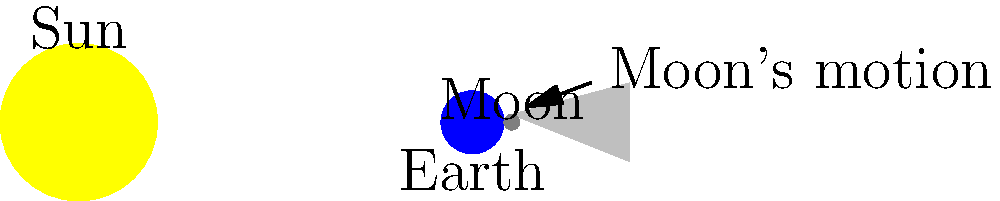In the diagram above, which represents a solar eclipse, why doesn't the contractor's shadow completely cover your view of the sun, unlike the Moon's shadow during a total solar eclipse? Let's break this down step-by-step:

1. In a solar eclipse, the Moon passes between the Earth and the Sun, casting a shadow on Earth.

2. The diagram shows the Sun (large yellow circle), Earth (blue circle), and Moon (small gray circle) aligned.

3. The Moon's shadow (gray triangle) extends towards Earth.

4. For a total solar eclipse to occur, the Moon must be at the right distance to completely cover the Sun's disk from Earth's perspective.

5. The Moon's average distance from Earth is about 384,400 km, while its diameter is about 3,475 km.

6. This specific size and distance combination allows the Moon to appear almost exactly the same size as the Sun in Earth's sky, despite the Sun being much larger but much farther away.

7. A contractor, being much closer to you than the Moon is to Earth, would not have the right size-to-distance ratio to completely cover the Sun from your perspective.

8. The contractor's shadow would appear much smaller relative to the Sun, leaving most of the Sun visible around the edges.

This phenomenon where the Moon can perfectly cover the Sun is a cosmic coincidence, making total solar eclipses possible and spectacular from Earth's surface.
Answer: The size-to-distance ratio of the Moon relative to the Sun allows for complete coverage, unlike a nearby contractor. 